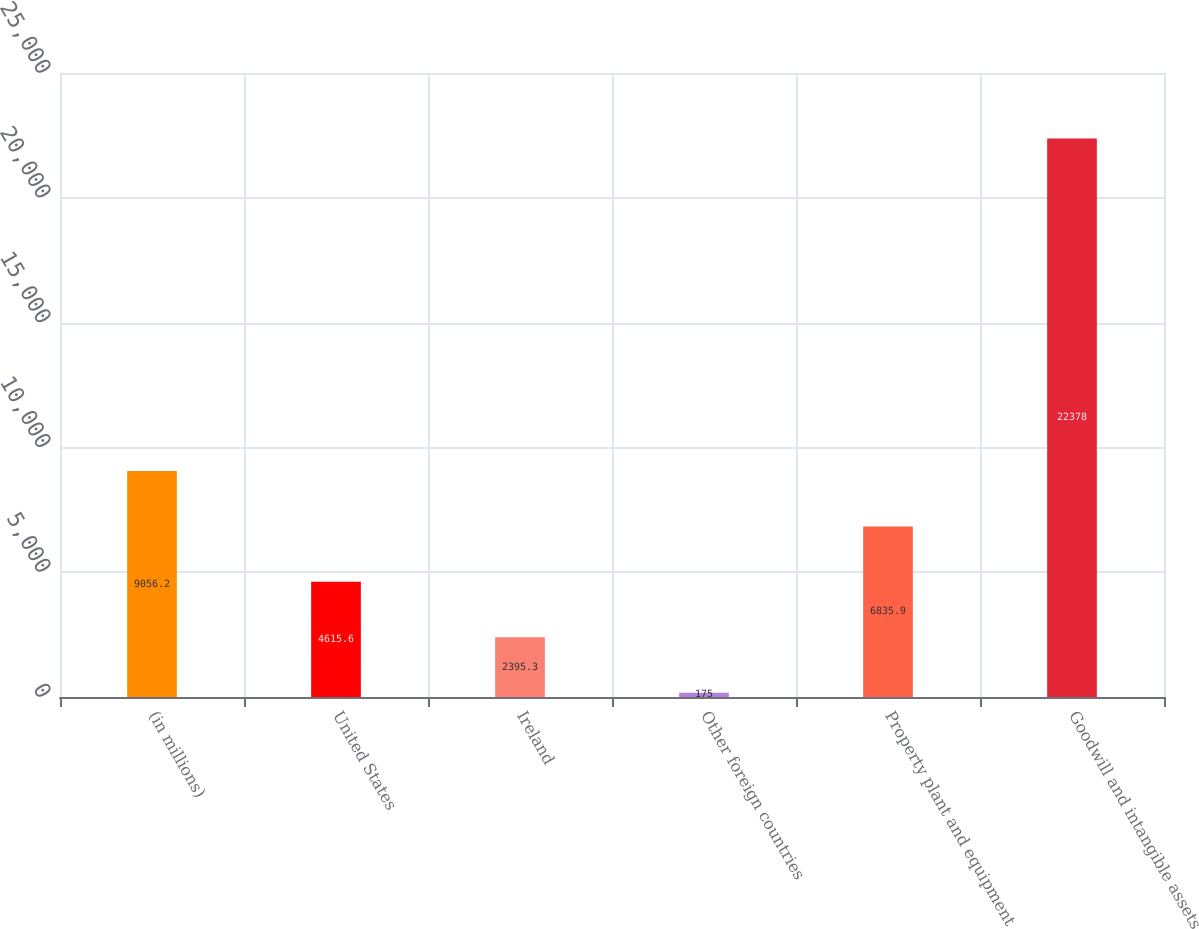<chart> <loc_0><loc_0><loc_500><loc_500><bar_chart><fcel>(in millions)<fcel>United States<fcel>Ireland<fcel>Other foreign countries<fcel>Property plant and equipment<fcel>Goodwill and intangible assets<nl><fcel>9056.2<fcel>4615.6<fcel>2395.3<fcel>175<fcel>6835.9<fcel>22378<nl></chart> 